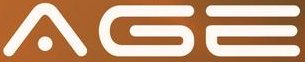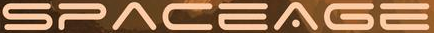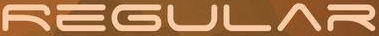Read the text from these images in sequence, separated by a semicolon. AGE; SPACEAGE; REGULAR 